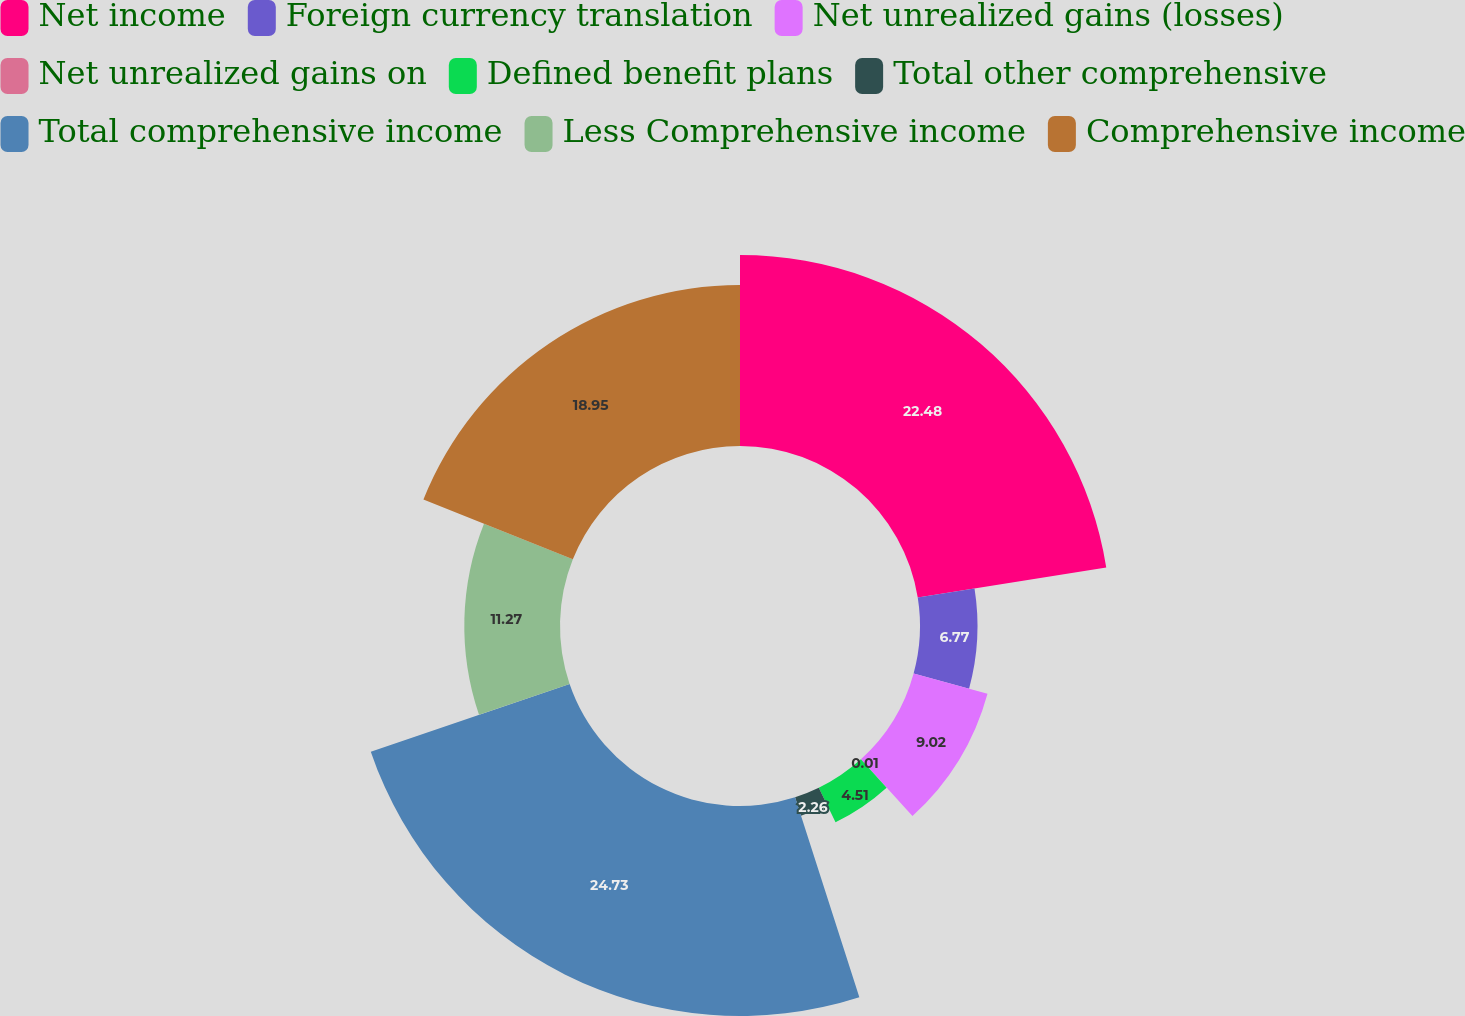Convert chart. <chart><loc_0><loc_0><loc_500><loc_500><pie_chart><fcel>Net income<fcel>Foreign currency translation<fcel>Net unrealized gains (losses)<fcel>Net unrealized gains on<fcel>Defined benefit plans<fcel>Total other comprehensive<fcel>Total comprehensive income<fcel>Less Comprehensive income<fcel>Comprehensive income<nl><fcel>22.48%<fcel>6.77%<fcel>9.02%<fcel>0.01%<fcel>4.51%<fcel>2.26%<fcel>24.73%<fcel>11.27%<fcel>18.95%<nl></chart> 